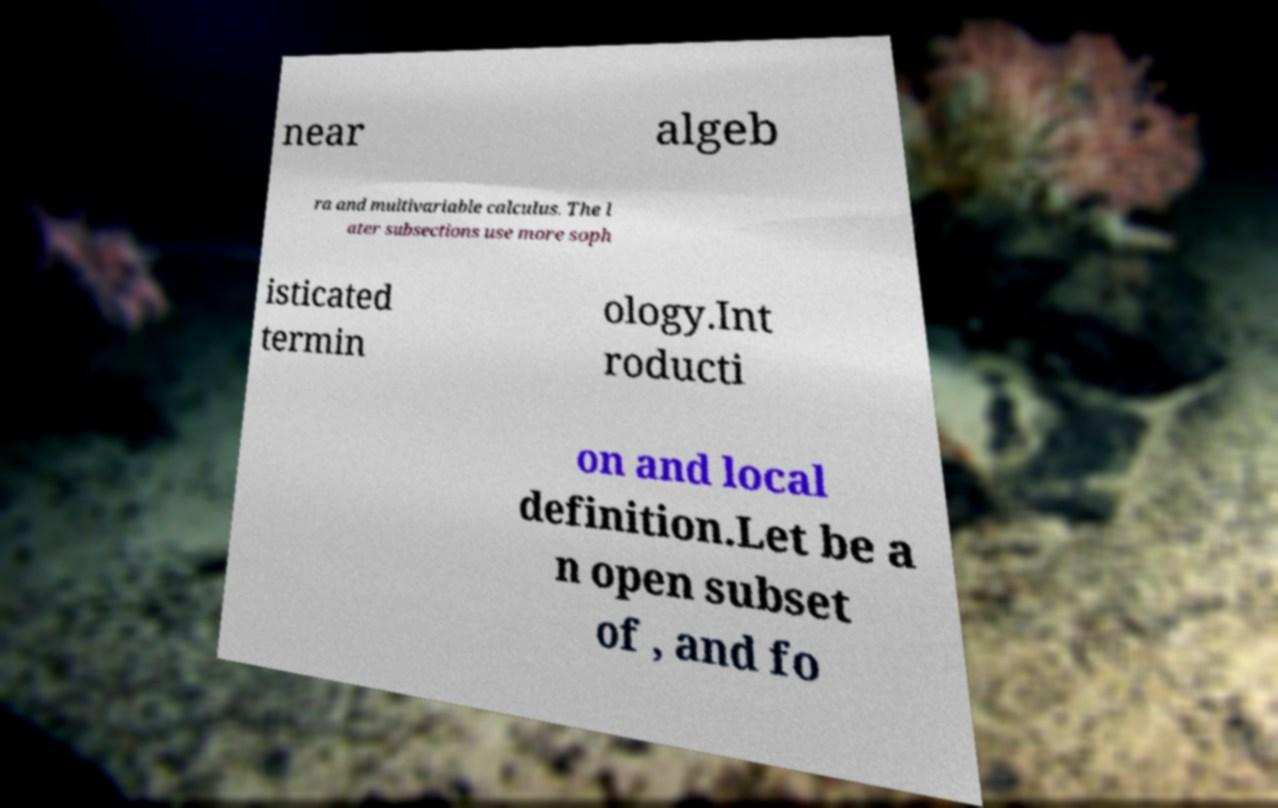What messages or text are displayed in this image? I need them in a readable, typed format. near algeb ra and multivariable calculus. The l ater subsections use more soph isticated termin ology.Int roducti on and local definition.Let be a n open subset of , and fo 